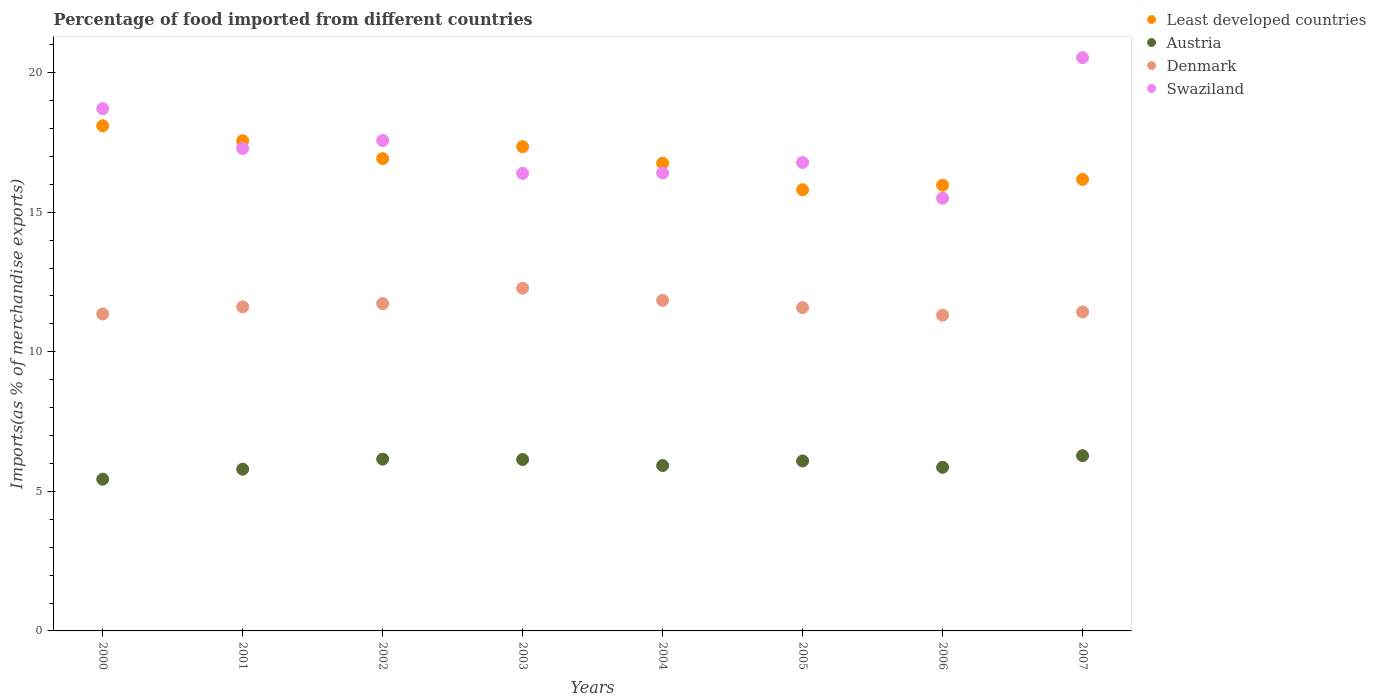What is the percentage of imports to different countries in Swaziland in 2006?
Offer a very short reply. 15.5. Across all years, what is the maximum percentage of imports to different countries in Austria?
Provide a succinct answer. 6.28. Across all years, what is the minimum percentage of imports to different countries in Least developed countries?
Offer a very short reply. 15.81. In which year was the percentage of imports to different countries in Denmark minimum?
Provide a short and direct response. 2006. What is the total percentage of imports to different countries in Denmark in the graph?
Provide a succinct answer. 93.14. What is the difference between the percentage of imports to different countries in Swaziland in 2000 and that in 2002?
Your answer should be very brief. 1.14. What is the difference between the percentage of imports to different countries in Swaziland in 2001 and the percentage of imports to different countries in Austria in 2005?
Offer a terse response. 11.2. What is the average percentage of imports to different countries in Swaziland per year?
Your response must be concise. 17.4. In the year 2000, what is the difference between the percentage of imports to different countries in Austria and percentage of imports to different countries in Least developed countries?
Make the answer very short. -12.66. In how many years, is the percentage of imports to different countries in Least developed countries greater than 2 %?
Provide a short and direct response. 8. What is the ratio of the percentage of imports to different countries in Austria in 2003 to that in 2006?
Give a very brief answer. 1.05. Is the percentage of imports to different countries in Denmark in 2003 less than that in 2006?
Offer a very short reply. No. Is the difference between the percentage of imports to different countries in Austria in 2001 and 2007 greater than the difference between the percentage of imports to different countries in Least developed countries in 2001 and 2007?
Your answer should be very brief. No. What is the difference between the highest and the second highest percentage of imports to different countries in Least developed countries?
Ensure brevity in your answer.  0.54. What is the difference between the highest and the lowest percentage of imports to different countries in Denmark?
Provide a succinct answer. 0.97. In how many years, is the percentage of imports to different countries in Denmark greater than the average percentage of imports to different countries in Denmark taken over all years?
Your response must be concise. 3. Is the sum of the percentage of imports to different countries in Least developed countries in 2005 and 2007 greater than the maximum percentage of imports to different countries in Austria across all years?
Keep it short and to the point. Yes. Is it the case that in every year, the sum of the percentage of imports to different countries in Denmark and percentage of imports to different countries in Austria  is greater than the percentage of imports to different countries in Least developed countries?
Offer a terse response. No. Does the percentage of imports to different countries in Swaziland monotonically increase over the years?
Your response must be concise. No. Is the percentage of imports to different countries in Austria strictly greater than the percentage of imports to different countries in Swaziland over the years?
Make the answer very short. No. What is the difference between two consecutive major ticks on the Y-axis?
Provide a succinct answer. 5. Are the values on the major ticks of Y-axis written in scientific E-notation?
Offer a terse response. No. Does the graph contain grids?
Your answer should be very brief. No. Where does the legend appear in the graph?
Your response must be concise. Top right. How many legend labels are there?
Offer a very short reply. 4. How are the legend labels stacked?
Your answer should be very brief. Vertical. What is the title of the graph?
Ensure brevity in your answer.  Percentage of food imported from different countries. Does "Upper middle income" appear as one of the legend labels in the graph?
Offer a very short reply. No. What is the label or title of the Y-axis?
Ensure brevity in your answer.  Imports(as % of merchandise exports). What is the Imports(as % of merchandise exports) of Least developed countries in 2000?
Provide a succinct answer. 18.1. What is the Imports(as % of merchandise exports) in Austria in 2000?
Offer a terse response. 5.44. What is the Imports(as % of merchandise exports) of Denmark in 2000?
Your response must be concise. 11.36. What is the Imports(as % of merchandise exports) of Swaziland in 2000?
Ensure brevity in your answer.  18.71. What is the Imports(as % of merchandise exports) in Least developed countries in 2001?
Offer a very short reply. 17.56. What is the Imports(as % of merchandise exports) in Austria in 2001?
Ensure brevity in your answer.  5.8. What is the Imports(as % of merchandise exports) in Denmark in 2001?
Offer a very short reply. 11.61. What is the Imports(as % of merchandise exports) in Swaziland in 2001?
Offer a very short reply. 17.29. What is the Imports(as % of merchandise exports) of Least developed countries in 2002?
Your response must be concise. 16.92. What is the Imports(as % of merchandise exports) of Austria in 2002?
Keep it short and to the point. 6.16. What is the Imports(as % of merchandise exports) in Denmark in 2002?
Offer a very short reply. 11.73. What is the Imports(as % of merchandise exports) in Swaziland in 2002?
Offer a terse response. 17.57. What is the Imports(as % of merchandise exports) of Least developed countries in 2003?
Offer a terse response. 17.35. What is the Imports(as % of merchandise exports) in Austria in 2003?
Your answer should be compact. 6.14. What is the Imports(as % of merchandise exports) in Denmark in 2003?
Your answer should be very brief. 12.28. What is the Imports(as % of merchandise exports) of Swaziland in 2003?
Make the answer very short. 16.39. What is the Imports(as % of merchandise exports) of Least developed countries in 2004?
Ensure brevity in your answer.  16.76. What is the Imports(as % of merchandise exports) in Austria in 2004?
Your answer should be compact. 5.92. What is the Imports(as % of merchandise exports) in Denmark in 2004?
Offer a very short reply. 11.84. What is the Imports(as % of merchandise exports) of Swaziland in 2004?
Offer a terse response. 16.41. What is the Imports(as % of merchandise exports) of Least developed countries in 2005?
Your response must be concise. 15.81. What is the Imports(as % of merchandise exports) in Austria in 2005?
Offer a terse response. 6.09. What is the Imports(as % of merchandise exports) in Denmark in 2005?
Offer a terse response. 11.58. What is the Imports(as % of merchandise exports) of Swaziland in 2005?
Offer a terse response. 16.78. What is the Imports(as % of merchandise exports) in Least developed countries in 2006?
Provide a succinct answer. 15.97. What is the Imports(as % of merchandise exports) in Austria in 2006?
Keep it short and to the point. 5.86. What is the Imports(as % of merchandise exports) of Denmark in 2006?
Your answer should be very brief. 11.31. What is the Imports(as % of merchandise exports) of Swaziland in 2006?
Make the answer very short. 15.5. What is the Imports(as % of merchandise exports) in Least developed countries in 2007?
Provide a short and direct response. 16.18. What is the Imports(as % of merchandise exports) of Austria in 2007?
Your answer should be compact. 6.28. What is the Imports(as % of merchandise exports) in Denmark in 2007?
Your answer should be very brief. 11.43. What is the Imports(as % of merchandise exports) in Swaziland in 2007?
Keep it short and to the point. 20.54. Across all years, what is the maximum Imports(as % of merchandise exports) in Least developed countries?
Ensure brevity in your answer.  18.1. Across all years, what is the maximum Imports(as % of merchandise exports) of Austria?
Offer a very short reply. 6.28. Across all years, what is the maximum Imports(as % of merchandise exports) of Denmark?
Provide a short and direct response. 12.28. Across all years, what is the maximum Imports(as % of merchandise exports) of Swaziland?
Offer a very short reply. 20.54. Across all years, what is the minimum Imports(as % of merchandise exports) in Least developed countries?
Provide a succinct answer. 15.81. Across all years, what is the minimum Imports(as % of merchandise exports) of Austria?
Offer a terse response. 5.44. Across all years, what is the minimum Imports(as % of merchandise exports) of Denmark?
Provide a succinct answer. 11.31. Across all years, what is the minimum Imports(as % of merchandise exports) in Swaziland?
Your answer should be very brief. 15.5. What is the total Imports(as % of merchandise exports) in Least developed countries in the graph?
Your response must be concise. 134.64. What is the total Imports(as % of merchandise exports) of Austria in the graph?
Provide a short and direct response. 47.68. What is the total Imports(as % of merchandise exports) in Denmark in the graph?
Offer a terse response. 93.14. What is the total Imports(as % of merchandise exports) of Swaziland in the graph?
Keep it short and to the point. 139.2. What is the difference between the Imports(as % of merchandise exports) in Least developed countries in 2000 and that in 2001?
Provide a short and direct response. 0.54. What is the difference between the Imports(as % of merchandise exports) of Austria in 2000 and that in 2001?
Keep it short and to the point. -0.36. What is the difference between the Imports(as % of merchandise exports) of Denmark in 2000 and that in 2001?
Ensure brevity in your answer.  -0.25. What is the difference between the Imports(as % of merchandise exports) of Swaziland in 2000 and that in 2001?
Offer a very short reply. 1.43. What is the difference between the Imports(as % of merchandise exports) in Least developed countries in 2000 and that in 2002?
Offer a terse response. 1.18. What is the difference between the Imports(as % of merchandise exports) in Austria in 2000 and that in 2002?
Offer a terse response. -0.72. What is the difference between the Imports(as % of merchandise exports) of Denmark in 2000 and that in 2002?
Your response must be concise. -0.37. What is the difference between the Imports(as % of merchandise exports) of Swaziland in 2000 and that in 2002?
Keep it short and to the point. 1.14. What is the difference between the Imports(as % of merchandise exports) in Least developed countries in 2000 and that in 2003?
Make the answer very short. 0.75. What is the difference between the Imports(as % of merchandise exports) in Austria in 2000 and that in 2003?
Your answer should be compact. -0.7. What is the difference between the Imports(as % of merchandise exports) of Denmark in 2000 and that in 2003?
Your answer should be very brief. -0.92. What is the difference between the Imports(as % of merchandise exports) in Swaziland in 2000 and that in 2003?
Your answer should be compact. 2.32. What is the difference between the Imports(as % of merchandise exports) in Least developed countries in 2000 and that in 2004?
Provide a short and direct response. 1.34. What is the difference between the Imports(as % of merchandise exports) of Austria in 2000 and that in 2004?
Make the answer very short. -0.49. What is the difference between the Imports(as % of merchandise exports) of Denmark in 2000 and that in 2004?
Provide a short and direct response. -0.49. What is the difference between the Imports(as % of merchandise exports) in Swaziland in 2000 and that in 2004?
Offer a terse response. 2.3. What is the difference between the Imports(as % of merchandise exports) in Least developed countries in 2000 and that in 2005?
Your response must be concise. 2.29. What is the difference between the Imports(as % of merchandise exports) of Austria in 2000 and that in 2005?
Give a very brief answer. -0.65. What is the difference between the Imports(as % of merchandise exports) in Denmark in 2000 and that in 2005?
Make the answer very short. -0.23. What is the difference between the Imports(as % of merchandise exports) in Swaziland in 2000 and that in 2005?
Your response must be concise. 1.93. What is the difference between the Imports(as % of merchandise exports) of Least developed countries in 2000 and that in 2006?
Provide a succinct answer. 2.13. What is the difference between the Imports(as % of merchandise exports) of Austria in 2000 and that in 2006?
Provide a succinct answer. -0.43. What is the difference between the Imports(as % of merchandise exports) in Denmark in 2000 and that in 2006?
Give a very brief answer. 0.04. What is the difference between the Imports(as % of merchandise exports) of Swaziland in 2000 and that in 2006?
Ensure brevity in your answer.  3.21. What is the difference between the Imports(as % of merchandise exports) of Least developed countries in 2000 and that in 2007?
Make the answer very short. 1.92. What is the difference between the Imports(as % of merchandise exports) of Austria in 2000 and that in 2007?
Provide a succinct answer. -0.84. What is the difference between the Imports(as % of merchandise exports) in Denmark in 2000 and that in 2007?
Provide a succinct answer. -0.07. What is the difference between the Imports(as % of merchandise exports) of Swaziland in 2000 and that in 2007?
Give a very brief answer. -1.83. What is the difference between the Imports(as % of merchandise exports) of Least developed countries in 2001 and that in 2002?
Provide a short and direct response. 0.64. What is the difference between the Imports(as % of merchandise exports) of Austria in 2001 and that in 2002?
Offer a terse response. -0.36. What is the difference between the Imports(as % of merchandise exports) in Denmark in 2001 and that in 2002?
Offer a terse response. -0.12. What is the difference between the Imports(as % of merchandise exports) in Swaziland in 2001 and that in 2002?
Keep it short and to the point. -0.28. What is the difference between the Imports(as % of merchandise exports) in Least developed countries in 2001 and that in 2003?
Give a very brief answer. 0.21. What is the difference between the Imports(as % of merchandise exports) of Austria in 2001 and that in 2003?
Your answer should be compact. -0.35. What is the difference between the Imports(as % of merchandise exports) of Denmark in 2001 and that in 2003?
Give a very brief answer. -0.67. What is the difference between the Imports(as % of merchandise exports) in Swaziland in 2001 and that in 2003?
Your answer should be compact. 0.89. What is the difference between the Imports(as % of merchandise exports) in Least developed countries in 2001 and that in 2004?
Make the answer very short. 0.81. What is the difference between the Imports(as % of merchandise exports) in Austria in 2001 and that in 2004?
Give a very brief answer. -0.13. What is the difference between the Imports(as % of merchandise exports) of Denmark in 2001 and that in 2004?
Give a very brief answer. -0.23. What is the difference between the Imports(as % of merchandise exports) of Swaziland in 2001 and that in 2004?
Ensure brevity in your answer.  0.88. What is the difference between the Imports(as % of merchandise exports) in Least developed countries in 2001 and that in 2005?
Offer a very short reply. 1.76. What is the difference between the Imports(as % of merchandise exports) in Austria in 2001 and that in 2005?
Keep it short and to the point. -0.29. What is the difference between the Imports(as % of merchandise exports) in Denmark in 2001 and that in 2005?
Provide a succinct answer. 0.03. What is the difference between the Imports(as % of merchandise exports) in Swaziland in 2001 and that in 2005?
Your answer should be very brief. 0.5. What is the difference between the Imports(as % of merchandise exports) of Least developed countries in 2001 and that in 2006?
Ensure brevity in your answer.  1.59. What is the difference between the Imports(as % of merchandise exports) of Austria in 2001 and that in 2006?
Keep it short and to the point. -0.07. What is the difference between the Imports(as % of merchandise exports) in Denmark in 2001 and that in 2006?
Make the answer very short. 0.3. What is the difference between the Imports(as % of merchandise exports) in Swaziland in 2001 and that in 2006?
Keep it short and to the point. 1.78. What is the difference between the Imports(as % of merchandise exports) in Least developed countries in 2001 and that in 2007?
Provide a short and direct response. 1.38. What is the difference between the Imports(as % of merchandise exports) of Austria in 2001 and that in 2007?
Provide a succinct answer. -0.48. What is the difference between the Imports(as % of merchandise exports) of Denmark in 2001 and that in 2007?
Make the answer very short. 0.18. What is the difference between the Imports(as % of merchandise exports) of Swaziland in 2001 and that in 2007?
Keep it short and to the point. -3.25. What is the difference between the Imports(as % of merchandise exports) in Least developed countries in 2002 and that in 2003?
Your answer should be compact. -0.43. What is the difference between the Imports(as % of merchandise exports) in Austria in 2002 and that in 2003?
Ensure brevity in your answer.  0.01. What is the difference between the Imports(as % of merchandise exports) of Denmark in 2002 and that in 2003?
Give a very brief answer. -0.55. What is the difference between the Imports(as % of merchandise exports) of Swaziland in 2002 and that in 2003?
Give a very brief answer. 1.18. What is the difference between the Imports(as % of merchandise exports) in Least developed countries in 2002 and that in 2004?
Your response must be concise. 0.17. What is the difference between the Imports(as % of merchandise exports) of Austria in 2002 and that in 2004?
Provide a short and direct response. 0.23. What is the difference between the Imports(as % of merchandise exports) of Denmark in 2002 and that in 2004?
Ensure brevity in your answer.  -0.11. What is the difference between the Imports(as % of merchandise exports) in Swaziland in 2002 and that in 2004?
Your answer should be very brief. 1.16. What is the difference between the Imports(as % of merchandise exports) of Least developed countries in 2002 and that in 2005?
Give a very brief answer. 1.11. What is the difference between the Imports(as % of merchandise exports) in Austria in 2002 and that in 2005?
Make the answer very short. 0.07. What is the difference between the Imports(as % of merchandise exports) of Denmark in 2002 and that in 2005?
Offer a terse response. 0.14. What is the difference between the Imports(as % of merchandise exports) in Swaziland in 2002 and that in 2005?
Your response must be concise. 0.79. What is the difference between the Imports(as % of merchandise exports) of Least developed countries in 2002 and that in 2006?
Provide a short and direct response. 0.95. What is the difference between the Imports(as % of merchandise exports) of Austria in 2002 and that in 2006?
Keep it short and to the point. 0.29. What is the difference between the Imports(as % of merchandise exports) in Denmark in 2002 and that in 2006?
Ensure brevity in your answer.  0.42. What is the difference between the Imports(as % of merchandise exports) in Swaziland in 2002 and that in 2006?
Give a very brief answer. 2.07. What is the difference between the Imports(as % of merchandise exports) of Least developed countries in 2002 and that in 2007?
Give a very brief answer. 0.74. What is the difference between the Imports(as % of merchandise exports) in Austria in 2002 and that in 2007?
Provide a short and direct response. -0.12. What is the difference between the Imports(as % of merchandise exports) in Denmark in 2002 and that in 2007?
Your response must be concise. 0.3. What is the difference between the Imports(as % of merchandise exports) of Swaziland in 2002 and that in 2007?
Give a very brief answer. -2.97. What is the difference between the Imports(as % of merchandise exports) of Least developed countries in 2003 and that in 2004?
Your response must be concise. 0.59. What is the difference between the Imports(as % of merchandise exports) of Austria in 2003 and that in 2004?
Ensure brevity in your answer.  0.22. What is the difference between the Imports(as % of merchandise exports) in Denmark in 2003 and that in 2004?
Provide a short and direct response. 0.44. What is the difference between the Imports(as % of merchandise exports) of Swaziland in 2003 and that in 2004?
Provide a short and direct response. -0.01. What is the difference between the Imports(as % of merchandise exports) in Least developed countries in 2003 and that in 2005?
Offer a terse response. 1.54. What is the difference between the Imports(as % of merchandise exports) of Austria in 2003 and that in 2005?
Ensure brevity in your answer.  0.05. What is the difference between the Imports(as % of merchandise exports) of Denmark in 2003 and that in 2005?
Make the answer very short. 0.69. What is the difference between the Imports(as % of merchandise exports) in Swaziland in 2003 and that in 2005?
Your answer should be very brief. -0.39. What is the difference between the Imports(as % of merchandise exports) in Least developed countries in 2003 and that in 2006?
Provide a succinct answer. 1.38. What is the difference between the Imports(as % of merchandise exports) of Austria in 2003 and that in 2006?
Give a very brief answer. 0.28. What is the difference between the Imports(as % of merchandise exports) of Denmark in 2003 and that in 2006?
Your response must be concise. 0.97. What is the difference between the Imports(as % of merchandise exports) in Swaziland in 2003 and that in 2006?
Offer a terse response. 0.89. What is the difference between the Imports(as % of merchandise exports) in Least developed countries in 2003 and that in 2007?
Offer a terse response. 1.17. What is the difference between the Imports(as % of merchandise exports) in Austria in 2003 and that in 2007?
Make the answer very short. -0.14. What is the difference between the Imports(as % of merchandise exports) of Denmark in 2003 and that in 2007?
Offer a terse response. 0.85. What is the difference between the Imports(as % of merchandise exports) of Swaziland in 2003 and that in 2007?
Provide a succinct answer. -4.14. What is the difference between the Imports(as % of merchandise exports) in Least developed countries in 2004 and that in 2005?
Your answer should be very brief. 0.95. What is the difference between the Imports(as % of merchandise exports) of Austria in 2004 and that in 2005?
Your answer should be compact. -0.16. What is the difference between the Imports(as % of merchandise exports) in Denmark in 2004 and that in 2005?
Provide a succinct answer. 0.26. What is the difference between the Imports(as % of merchandise exports) in Swaziland in 2004 and that in 2005?
Your response must be concise. -0.38. What is the difference between the Imports(as % of merchandise exports) of Least developed countries in 2004 and that in 2006?
Your response must be concise. 0.79. What is the difference between the Imports(as % of merchandise exports) of Austria in 2004 and that in 2006?
Keep it short and to the point. 0.06. What is the difference between the Imports(as % of merchandise exports) of Denmark in 2004 and that in 2006?
Give a very brief answer. 0.53. What is the difference between the Imports(as % of merchandise exports) in Swaziland in 2004 and that in 2006?
Make the answer very short. 0.9. What is the difference between the Imports(as % of merchandise exports) in Least developed countries in 2004 and that in 2007?
Offer a terse response. 0.58. What is the difference between the Imports(as % of merchandise exports) in Austria in 2004 and that in 2007?
Your answer should be very brief. -0.35. What is the difference between the Imports(as % of merchandise exports) in Denmark in 2004 and that in 2007?
Provide a succinct answer. 0.42. What is the difference between the Imports(as % of merchandise exports) in Swaziland in 2004 and that in 2007?
Ensure brevity in your answer.  -4.13. What is the difference between the Imports(as % of merchandise exports) in Least developed countries in 2005 and that in 2006?
Provide a short and direct response. -0.16. What is the difference between the Imports(as % of merchandise exports) of Austria in 2005 and that in 2006?
Ensure brevity in your answer.  0.23. What is the difference between the Imports(as % of merchandise exports) of Denmark in 2005 and that in 2006?
Provide a succinct answer. 0.27. What is the difference between the Imports(as % of merchandise exports) of Swaziland in 2005 and that in 2006?
Your answer should be compact. 1.28. What is the difference between the Imports(as % of merchandise exports) in Least developed countries in 2005 and that in 2007?
Make the answer very short. -0.37. What is the difference between the Imports(as % of merchandise exports) in Austria in 2005 and that in 2007?
Offer a very short reply. -0.19. What is the difference between the Imports(as % of merchandise exports) of Denmark in 2005 and that in 2007?
Offer a very short reply. 0.16. What is the difference between the Imports(as % of merchandise exports) of Swaziland in 2005 and that in 2007?
Provide a short and direct response. -3.76. What is the difference between the Imports(as % of merchandise exports) in Least developed countries in 2006 and that in 2007?
Provide a succinct answer. -0.21. What is the difference between the Imports(as % of merchandise exports) in Austria in 2006 and that in 2007?
Ensure brevity in your answer.  -0.41. What is the difference between the Imports(as % of merchandise exports) of Denmark in 2006 and that in 2007?
Offer a terse response. -0.11. What is the difference between the Imports(as % of merchandise exports) in Swaziland in 2006 and that in 2007?
Your response must be concise. -5.04. What is the difference between the Imports(as % of merchandise exports) in Least developed countries in 2000 and the Imports(as % of merchandise exports) in Austria in 2001?
Ensure brevity in your answer.  12.3. What is the difference between the Imports(as % of merchandise exports) of Least developed countries in 2000 and the Imports(as % of merchandise exports) of Denmark in 2001?
Provide a short and direct response. 6.49. What is the difference between the Imports(as % of merchandise exports) in Least developed countries in 2000 and the Imports(as % of merchandise exports) in Swaziland in 2001?
Give a very brief answer. 0.81. What is the difference between the Imports(as % of merchandise exports) in Austria in 2000 and the Imports(as % of merchandise exports) in Denmark in 2001?
Provide a succinct answer. -6.17. What is the difference between the Imports(as % of merchandise exports) of Austria in 2000 and the Imports(as % of merchandise exports) of Swaziland in 2001?
Give a very brief answer. -11.85. What is the difference between the Imports(as % of merchandise exports) in Denmark in 2000 and the Imports(as % of merchandise exports) in Swaziland in 2001?
Give a very brief answer. -5.93. What is the difference between the Imports(as % of merchandise exports) in Least developed countries in 2000 and the Imports(as % of merchandise exports) in Austria in 2002?
Give a very brief answer. 11.94. What is the difference between the Imports(as % of merchandise exports) of Least developed countries in 2000 and the Imports(as % of merchandise exports) of Denmark in 2002?
Offer a terse response. 6.37. What is the difference between the Imports(as % of merchandise exports) of Least developed countries in 2000 and the Imports(as % of merchandise exports) of Swaziland in 2002?
Keep it short and to the point. 0.53. What is the difference between the Imports(as % of merchandise exports) in Austria in 2000 and the Imports(as % of merchandise exports) in Denmark in 2002?
Offer a terse response. -6.29. What is the difference between the Imports(as % of merchandise exports) of Austria in 2000 and the Imports(as % of merchandise exports) of Swaziland in 2002?
Give a very brief answer. -12.13. What is the difference between the Imports(as % of merchandise exports) in Denmark in 2000 and the Imports(as % of merchandise exports) in Swaziland in 2002?
Your answer should be compact. -6.21. What is the difference between the Imports(as % of merchandise exports) of Least developed countries in 2000 and the Imports(as % of merchandise exports) of Austria in 2003?
Provide a succinct answer. 11.96. What is the difference between the Imports(as % of merchandise exports) of Least developed countries in 2000 and the Imports(as % of merchandise exports) of Denmark in 2003?
Provide a short and direct response. 5.82. What is the difference between the Imports(as % of merchandise exports) of Least developed countries in 2000 and the Imports(as % of merchandise exports) of Swaziland in 2003?
Provide a short and direct response. 1.7. What is the difference between the Imports(as % of merchandise exports) in Austria in 2000 and the Imports(as % of merchandise exports) in Denmark in 2003?
Offer a very short reply. -6.84. What is the difference between the Imports(as % of merchandise exports) of Austria in 2000 and the Imports(as % of merchandise exports) of Swaziland in 2003?
Provide a succinct answer. -10.96. What is the difference between the Imports(as % of merchandise exports) in Denmark in 2000 and the Imports(as % of merchandise exports) in Swaziland in 2003?
Provide a succinct answer. -5.04. What is the difference between the Imports(as % of merchandise exports) of Least developed countries in 2000 and the Imports(as % of merchandise exports) of Austria in 2004?
Provide a short and direct response. 12.17. What is the difference between the Imports(as % of merchandise exports) in Least developed countries in 2000 and the Imports(as % of merchandise exports) in Denmark in 2004?
Provide a short and direct response. 6.26. What is the difference between the Imports(as % of merchandise exports) in Least developed countries in 2000 and the Imports(as % of merchandise exports) in Swaziland in 2004?
Provide a short and direct response. 1.69. What is the difference between the Imports(as % of merchandise exports) in Austria in 2000 and the Imports(as % of merchandise exports) in Denmark in 2004?
Provide a succinct answer. -6.41. What is the difference between the Imports(as % of merchandise exports) in Austria in 2000 and the Imports(as % of merchandise exports) in Swaziland in 2004?
Give a very brief answer. -10.97. What is the difference between the Imports(as % of merchandise exports) in Denmark in 2000 and the Imports(as % of merchandise exports) in Swaziland in 2004?
Offer a very short reply. -5.05. What is the difference between the Imports(as % of merchandise exports) in Least developed countries in 2000 and the Imports(as % of merchandise exports) in Austria in 2005?
Make the answer very short. 12.01. What is the difference between the Imports(as % of merchandise exports) in Least developed countries in 2000 and the Imports(as % of merchandise exports) in Denmark in 2005?
Provide a succinct answer. 6.52. What is the difference between the Imports(as % of merchandise exports) in Least developed countries in 2000 and the Imports(as % of merchandise exports) in Swaziland in 2005?
Provide a succinct answer. 1.32. What is the difference between the Imports(as % of merchandise exports) in Austria in 2000 and the Imports(as % of merchandise exports) in Denmark in 2005?
Give a very brief answer. -6.15. What is the difference between the Imports(as % of merchandise exports) of Austria in 2000 and the Imports(as % of merchandise exports) of Swaziland in 2005?
Your answer should be compact. -11.35. What is the difference between the Imports(as % of merchandise exports) in Denmark in 2000 and the Imports(as % of merchandise exports) in Swaziland in 2005?
Your response must be concise. -5.43. What is the difference between the Imports(as % of merchandise exports) in Least developed countries in 2000 and the Imports(as % of merchandise exports) in Austria in 2006?
Give a very brief answer. 12.24. What is the difference between the Imports(as % of merchandise exports) in Least developed countries in 2000 and the Imports(as % of merchandise exports) in Denmark in 2006?
Your response must be concise. 6.79. What is the difference between the Imports(as % of merchandise exports) of Least developed countries in 2000 and the Imports(as % of merchandise exports) of Swaziland in 2006?
Offer a very short reply. 2.6. What is the difference between the Imports(as % of merchandise exports) of Austria in 2000 and the Imports(as % of merchandise exports) of Denmark in 2006?
Give a very brief answer. -5.88. What is the difference between the Imports(as % of merchandise exports) of Austria in 2000 and the Imports(as % of merchandise exports) of Swaziland in 2006?
Your response must be concise. -10.07. What is the difference between the Imports(as % of merchandise exports) of Denmark in 2000 and the Imports(as % of merchandise exports) of Swaziland in 2006?
Provide a succinct answer. -4.15. What is the difference between the Imports(as % of merchandise exports) of Least developed countries in 2000 and the Imports(as % of merchandise exports) of Austria in 2007?
Ensure brevity in your answer.  11.82. What is the difference between the Imports(as % of merchandise exports) in Least developed countries in 2000 and the Imports(as % of merchandise exports) in Denmark in 2007?
Your answer should be very brief. 6.67. What is the difference between the Imports(as % of merchandise exports) in Least developed countries in 2000 and the Imports(as % of merchandise exports) in Swaziland in 2007?
Offer a terse response. -2.44. What is the difference between the Imports(as % of merchandise exports) of Austria in 2000 and the Imports(as % of merchandise exports) of Denmark in 2007?
Offer a very short reply. -5.99. What is the difference between the Imports(as % of merchandise exports) in Austria in 2000 and the Imports(as % of merchandise exports) in Swaziland in 2007?
Offer a terse response. -15.1. What is the difference between the Imports(as % of merchandise exports) in Denmark in 2000 and the Imports(as % of merchandise exports) in Swaziland in 2007?
Make the answer very short. -9.18. What is the difference between the Imports(as % of merchandise exports) in Least developed countries in 2001 and the Imports(as % of merchandise exports) in Austria in 2002?
Keep it short and to the point. 11.41. What is the difference between the Imports(as % of merchandise exports) of Least developed countries in 2001 and the Imports(as % of merchandise exports) of Denmark in 2002?
Offer a very short reply. 5.83. What is the difference between the Imports(as % of merchandise exports) in Least developed countries in 2001 and the Imports(as % of merchandise exports) in Swaziland in 2002?
Your response must be concise. -0.01. What is the difference between the Imports(as % of merchandise exports) of Austria in 2001 and the Imports(as % of merchandise exports) of Denmark in 2002?
Offer a very short reply. -5.93. What is the difference between the Imports(as % of merchandise exports) of Austria in 2001 and the Imports(as % of merchandise exports) of Swaziland in 2002?
Provide a succinct answer. -11.78. What is the difference between the Imports(as % of merchandise exports) in Denmark in 2001 and the Imports(as % of merchandise exports) in Swaziland in 2002?
Keep it short and to the point. -5.96. What is the difference between the Imports(as % of merchandise exports) in Least developed countries in 2001 and the Imports(as % of merchandise exports) in Austria in 2003?
Provide a short and direct response. 11.42. What is the difference between the Imports(as % of merchandise exports) of Least developed countries in 2001 and the Imports(as % of merchandise exports) of Denmark in 2003?
Your answer should be compact. 5.28. What is the difference between the Imports(as % of merchandise exports) of Least developed countries in 2001 and the Imports(as % of merchandise exports) of Swaziland in 2003?
Your response must be concise. 1.17. What is the difference between the Imports(as % of merchandise exports) in Austria in 2001 and the Imports(as % of merchandise exports) in Denmark in 2003?
Offer a very short reply. -6.48. What is the difference between the Imports(as % of merchandise exports) in Austria in 2001 and the Imports(as % of merchandise exports) in Swaziland in 2003?
Offer a very short reply. -10.6. What is the difference between the Imports(as % of merchandise exports) in Denmark in 2001 and the Imports(as % of merchandise exports) in Swaziland in 2003?
Offer a very short reply. -4.78. What is the difference between the Imports(as % of merchandise exports) of Least developed countries in 2001 and the Imports(as % of merchandise exports) of Austria in 2004?
Provide a succinct answer. 11.64. What is the difference between the Imports(as % of merchandise exports) in Least developed countries in 2001 and the Imports(as % of merchandise exports) in Denmark in 2004?
Ensure brevity in your answer.  5.72. What is the difference between the Imports(as % of merchandise exports) of Least developed countries in 2001 and the Imports(as % of merchandise exports) of Swaziland in 2004?
Keep it short and to the point. 1.15. What is the difference between the Imports(as % of merchandise exports) of Austria in 2001 and the Imports(as % of merchandise exports) of Denmark in 2004?
Your answer should be very brief. -6.05. What is the difference between the Imports(as % of merchandise exports) of Austria in 2001 and the Imports(as % of merchandise exports) of Swaziland in 2004?
Make the answer very short. -10.61. What is the difference between the Imports(as % of merchandise exports) of Denmark in 2001 and the Imports(as % of merchandise exports) of Swaziland in 2004?
Offer a terse response. -4.8. What is the difference between the Imports(as % of merchandise exports) of Least developed countries in 2001 and the Imports(as % of merchandise exports) of Austria in 2005?
Ensure brevity in your answer.  11.47. What is the difference between the Imports(as % of merchandise exports) in Least developed countries in 2001 and the Imports(as % of merchandise exports) in Denmark in 2005?
Make the answer very short. 5.98. What is the difference between the Imports(as % of merchandise exports) in Least developed countries in 2001 and the Imports(as % of merchandise exports) in Swaziland in 2005?
Give a very brief answer. 0.78. What is the difference between the Imports(as % of merchandise exports) of Austria in 2001 and the Imports(as % of merchandise exports) of Denmark in 2005?
Your response must be concise. -5.79. What is the difference between the Imports(as % of merchandise exports) in Austria in 2001 and the Imports(as % of merchandise exports) in Swaziland in 2005?
Ensure brevity in your answer.  -10.99. What is the difference between the Imports(as % of merchandise exports) in Denmark in 2001 and the Imports(as % of merchandise exports) in Swaziland in 2005?
Ensure brevity in your answer.  -5.17. What is the difference between the Imports(as % of merchandise exports) of Least developed countries in 2001 and the Imports(as % of merchandise exports) of Austria in 2006?
Provide a succinct answer. 11.7. What is the difference between the Imports(as % of merchandise exports) in Least developed countries in 2001 and the Imports(as % of merchandise exports) in Denmark in 2006?
Provide a succinct answer. 6.25. What is the difference between the Imports(as % of merchandise exports) in Least developed countries in 2001 and the Imports(as % of merchandise exports) in Swaziland in 2006?
Offer a terse response. 2.06. What is the difference between the Imports(as % of merchandise exports) in Austria in 2001 and the Imports(as % of merchandise exports) in Denmark in 2006?
Provide a succinct answer. -5.52. What is the difference between the Imports(as % of merchandise exports) of Austria in 2001 and the Imports(as % of merchandise exports) of Swaziland in 2006?
Your response must be concise. -9.71. What is the difference between the Imports(as % of merchandise exports) in Denmark in 2001 and the Imports(as % of merchandise exports) in Swaziland in 2006?
Your response must be concise. -3.89. What is the difference between the Imports(as % of merchandise exports) in Least developed countries in 2001 and the Imports(as % of merchandise exports) in Austria in 2007?
Give a very brief answer. 11.29. What is the difference between the Imports(as % of merchandise exports) in Least developed countries in 2001 and the Imports(as % of merchandise exports) in Denmark in 2007?
Provide a short and direct response. 6.14. What is the difference between the Imports(as % of merchandise exports) of Least developed countries in 2001 and the Imports(as % of merchandise exports) of Swaziland in 2007?
Offer a very short reply. -2.98. What is the difference between the Imports(as % of merchandise exports) in Austria in 2001 and the Imports(as % of merchandise exports) in Denmark in 2007?
Your response must be concise. -5.63. What is the difference between the Imports(as % of merchandise exports) of Austria in 2001 and the Imports(as % of merchandise exports) of Swaziland in 2007?
Ensure brevity in your answer.  -14.74. What is the difference between the Imports(as % of merchandise exports) of Denmark in 2001 and the Imports(as % of merchandise exports) of Swaziland in 2007?
Make the answer very short. -8.93. What is the difference between the Imports(as % of merchandise exports) of Least developed countries in 2002 and the Imports(as % of merchandise exports) of Austria in 2003?
Your answer should be compact. 10.78. What is the difference between the Imports(as % of merchandise exports) of Least developed countries in 2002 and the Imports(as % of merchandise exports) of Denmark in 2003?
Your answer should be compact. 4.64. What is the difference between the Imports(as % of merchandise exports) in Least developed countries in 2002 and the Imports(as % of merchandise exports) in Swaziland in 2003?
Give a very brief answer. 0.53. What is the difference between the Imports(as % of merchandise exports) in Austria in 2002 and the Imports(as % of merchandise exports) in Denmark in 2003?
Offer a terse response. -6.12. What is the difference between the Imports(as % of merchandise exports) in Austria in 2002 and the Imports(as % of merchandise exports) in Swaziland in 2003?
Give a very brief answer. -10.24. What is the difference between the Imports(as % of merchandise exports) of Denmark in 2002 and the Imports(as % of merchandise exports) of Swaziland in 2003?
Offer a very short reply. -4.67. What is the difference between the Imports(as % of merchandise exports) of Least developed countries in 2002 and the Imports(as % of merchandise exports) of Austria in 2004?
Make the answer very short. 11. What is the difference between the Imports(as % of merchandise exports) of Least developed countries in 2002 and the Imports(as % of merchandise exports) of Denmark in 2004?
Your answer should be compact. 5.08. What is the difference between the Imports(as % of merchandise exports) of Least developed countries in 2002 and the Imports(as % of merchandise exports) of Swaziland in 2004?
Provide a succinct answer. 0.51. What is the difference between the Imports(as % of merchandise exports) of Austria in 2002 and the Imports(as % of merchandise exports) of Denmark in 2004?
Your answer should be compact. -5.69. What is the difference between the Imports(as % of merchandise exports) of Austria in 2002 and the Imports(as % of merchandise exports) of Swaziland in 2004?
Your response must be concise. -10.25. What is the difference between the Imports(as % of merchandise exports) in Denmark in 2002 and the Imports(as % of merchandise exports) in Swaziland in 2004?
Ensure brevity in your answer.  -4.68. What is the difference between the Imports(as % of merchandise exports) of Least developed countries in 2002 and the Imports(as % of merchandise exports) of Austria in 2005?
Offer a terse response. 10.83. What is the difference between the Imports(as % of merchandise exports) of Least developed countries in 2002 and the Imports(as % of merchandise exports) of Denmark in 2005?
Provide a short and direct response. 5.34. What is the difference between the Imports(as % of merchandise exports) in Least developed countries in 2002 and the Imports(as % of merchandise exports) in Swaziland in 2005?
Your answer should be compact. 0.14. What is the difference between the Imports(as % of merchandise exports) of Austria in 2002 and the Imports(as % of merchandise exports) of Denmark in 2005?
Offer a terse response. -5.43. What is the difference between the Imports(as % of merchandise exports) of Austria in 2002 and the Imports(as % of merchandise exports) of Swaziland in 2005?
Offer a very short reply. -10.63. What is the difference between the Imports(as % of merchandise exports) of Denmark in 2002 and the Imports(as % of merchandise exports) of Swaziland in 2005?
Provide a short and direct response. -5.05. What is the difference between the Imports(as % of merchandise exports) of Least developed countries in 2002 and the Imports(as % of merchandise exports) of Austria in 2006?
Offer a very short reply. 11.06. What is the difference between the Imports(as % of merchandise exports) of Least developed countries in 2002 and the Imports(as % of merchandise exports) of Denmark in 2006?
Your response must be concise. 5.61. What is the difference between the Imports(as % of merchandise exports) in Least developed countries in 2002 and the Imports(as % of merchandise exports) in Swaziland in 2006?
Offer a terse response. 1.42. What is the difference between the Imports(as % of merchandise exports) in Austria in 2002 and the Imports(as % of merchandise exports) in Denmark in 2006?
Give a very brief answer. -5.16. What is the difference between the Imports(as % of merchandise exports) in Austria in 2002 and the Imports(as % of merchandise exports) in Swaziland in 2006?
Your response must be concise. -9.35. What is the difference between the Imports(as % of merchandise exports) of Denmark in 2002 and the Imports(as % of merchandise exports) of Swaziland in 2006?
Make the answer very short. -3.78. What is the difference between the Imports(as % of merchandise exports) of Least developed countries in 2002 and the Imports(as % of merchandise exports) of Austria in 2007?
Provide a short and direct response. 10.64. What is the difference between the Imports(as % of merchandise exports) of Least developed countries in 2002 and the Imports(as % of merchandise exports) of Denmark in 2007?
Keep it short and to the point. 5.5. What is the difference between the Imports(as % of merchandise exports) of Least developed countries in 2002 and the Imports(as % of merchandise exports) of Swaziland in 2007?
Ensure brevity in your answer.  -3.62. What is the difference between the Imports(as % of merchandise exports) of Austria in 2002 and the Imports(as % of merchandise exports) of Denmark in 2007?
Your answer should be compact. -5.27. What is the difference between the Imports(as % of merchandise exports) of Austria in 2002 and the Imports(as % of merchandise exports) of Swaziland in 2007?
Provide a short and direct response. -14.38. What is the difference between the Imports(as % of merchandise exports) in Denmark in 2002 and the Imports(as % of merchandise exports) in Swaziland in 2007?
Provide a succinct answer. -8.81. What is the difference between the Imports(as % of merchandise exports) of Least developed countries in 2003 and the Imports(as % of merchandise exports) of Austria in 2004?
Ensure brevity in your answer.  11.42. What is the difference between the Imports(as % of merchandise exports) in Least developed countries in 2003 and the Imports(as % of merchandise exports) in Denmark in 2004?
Provide a short and direct response. 5.51. What is the difference between the Imports(as % of merchandise exports) in Least developed countries in 2003 and the Imports(as % of merchandise exports) in Swaziland in 2004?
Your answer should be compact. 0.94. What is the difference between the Imports(as % of merchandise exports) of Austria in 2003 and the Imports(as % of merchandise exports) of Denmark in 2004?
Offer a terse response. -5.7. What is the difference between the Imports(as % of merchandise exports) in Austria in 2003 and the Imports(as % of merchandise exports) in Swaziland in 2004?
Make the answer very short. -10.27. What is the difference between the Imports(as % of merchandise exports) in Denmark in 2003 and the Imports(as % of merchandise exports) in Swaziland in 2004?
Your answer should be compact. -4.13. What is the difference between the Imports(as % of merchandise exports) in Least developed countries in 2003 and the Imports(as % of merchandise exports) in Austria in 2005?
Offer a terse response. 11.26. What is the difference between the Imports(as % of merchandise exports) in Least developed countries in 2003 and the Imports(as % of merchandise exports) in Denmark in 2005?
Give a very brief answer. 5.76. What is the difference between the Imports(as % of merchandise exports) of Least developed countries in 2003 and the Imports(as % of merchandise exports) of Swaziland in 2005?
Offer a very short reply. 0.57. What is the difference between the Imports(as % of merchandise exports) of Austria in 2003 and the Imports(as % of merchandise exports) of Denmark in 2005?
Provide a succinct answer. -5.44. What is the difference between the Imports(as % of merchandise exports) in Austria in 2003 and the Imports(as % of merchandise exports) in Swaziland in 2005?
Your answer should be compact. -10.64. What is the difference between the Imports(as % of merchandise exports) in Denmark in 2003 and the Imports(as % of merchandise exports) in Swaziland in 2005?
Keep it short and to the point. -4.5. What is the difference between the Imports(as % of merchandise exports) in Least developed countries in 2003 and the Imports(as % of merchandise exports) in Austria in 2006?
Ensure brevity in your answer.  11.49. What is the difference between the Imports(as % of merchandise exports) in Least developed countries in 2003 and the Imports(as % of merchandise exports) in Denmark in 2006?
Offer a terse response. 6.04. What is the difference between the Imports(as % of merchandise exports) in Least developed countries in 2003 and the Imports(as % of merchandise exports) in Swaziland in 2006?
Give a very brief answer. 1.84. What is the difference between the Imports(as % of merchandise exports) of Austria in 2003 and the Imports(as % of merchandise exports) of Denmark in 2006?
Make the answer very short. -5.17. What is the difference between the Imports(as % of merchandise exports) of Austria in 2003 and the Imports(as % of merchandise exports) of Swaziland in 2006?
Provide a short and direct response. -9.36. What is the difference between the Imports(as % of merchandise exports) of Denmark in 2003 and the Imports(as % of merchandise exports) of Swaziland in 2006?
Make the answer very short. -3.23. What is the difference between the Imports(as % of merchandise exports) of Least developed countries in 2003 and the Imports(as % of merchandise exports) of Austria in 2007?
Offer a terse response. 11.07. What is the difference between the Imports(as % of merchandise exports) in Least developed countries in 2003 and the Imports(as % of merchandise exports) in Denmark in 2007?
Offer a terse response. 5.92. What is the difference between the Imports(as % of merchandise exports) in Least developed countries in 2003 and the Imports(as % of merchandise exports) in Swaziland in 2007?
Provide a short and direct response. -3.19. What is the difference between the Imports(as % of merchandise exports) of Austria in 2003 and the Imports(as % of merchandise exports) of Denmark in 2007?
Your answer should be compact. -5.29. What is the difference between the Imports(as % of merchandise exports) of Austria in 2003 and the Imports(as % of merchandise exports) of Swaziland in 2007?
Your answer should be very brief. -14.4. What is the difference between the Imports(as % of merchandise exports) in Denmark in 2003 and the Imports(as % of merchandise exports) in Swaziland in 2007?
Provide a short and direct response. -8.26. What is the difference between the Imports(as % of merchandise exports) of Least developed countries in 2004 and the Imports(as % of merchandise exports) of Austria in 2005?
Offer a very short reply. 10.67. What is the difference between the Imports(as % of merchandise exports) of Least developed countries in 2004 and the Imports(as % of merchandise exports) of Denmark in 2005?
Your answer should be compact. 5.17. What is the difference between the Imports(as % of merchandise exports) in Least developed countries in 2004 and the Imports(as % of merchandise exports) in Swaziland in 2005?
Make the answer very short. -0.03. What is the difference between the Imports(as % of merchandise exports) of Austria in 2004 and the Imports(as % of merchandise exports) of Denmark in 2005?
Provide a succinct answer. -5.66. What is the difference between the Imports(as % of merchandise exports) of Austria in 2004 and the Imports(as % of merchandise exports) of Swaziland in 2005?
Provide a succinct answer. -10.86. What is the difference between the Imports(as % of merchandise exports) in Denmark in 2004 and the Imports(as % of merchandise exports) in Swaziland in 2005?
Your answer should be compact. -4.94. What is the difference between the Imports(as % of merchandise exports) in Least developed countries in 2004 and the Imports(as % of merchandise exports) in Austria in 2006?
Keep it short and to the point. 10.89. What is the difference between the Imports(as % of merchandise exports) of Least developed countries in 2004 and the Imports(as % of merchandise exports) of Denmark in 2006?
Make the answer very short. 5.44. What is the difference between the Imports(as % of merchandise exports) of Least developed countries in 2004 and the Imports(as % of merchandise exports) of Swaziland in 2006?
Provide a succinct answer. 1.25. What is the difference between the Imports(as % of merchandise exports) in Austria in 2004 and the Imports(as % of merchandise exports) in Denmark in 2006?
Your answer should be very brief. -5.39. What is the difference between the Imports(as % of merchandise exports) of Austria in 2004 and the Imports(as % of merchandise exports) of Swaziland in 2006?
Provide a succinct answer. -9.58. What is the difference between the Imports(as % of merchandise exports) of Denmark in 2004 and the Imports(as % of merchandise exports) of Swaziland in 2006?
Provide a succinct answer. -3.66. What is the difference between the Imports(as % of merchandise exports) in Least developed countries in 2004 and the Imports(as % of merchandise exports) in Austria in 2007?
Provide a succinct answer. 10.48. What is the difference between the Imports(as % of merchandise exports) of Least developed countries in 2004 and the Imports(as % of merchandise exports) of Denmark in 2007?
Provide a short and direct response. 5.33. What is the difference between the Imports(as % of merchandise exports) of Least developed countries in 2004 and the Imports(as % of merchandise exports) of Swaziland in 2007?
Ensure brevity in your answer.  -3.78. What is the difference between the Imports(as % of merchandise exports) in Austria in 2004 and the Imports(as % of merchandise exports) in Denmark in 2007?
Offer a very short reply. -5.5. What is the difference between the Imports(as % of merchandise exports) in Austria in 2004 and the Imports(as % of merchandise exports) in Swaziland in 2007?
Your answer should be compact. -14.61. What is the difference between the Imports(as % of merchandise exports) in Denmark in 2004 and the Imports(as % of merchandise exports) in Swaziland in 2007?
Offer a terse response. -8.7. What is the difference between the Imports(as % of merchandise exports) in Least developed countries in 2005 and the Imports(as % of merchandise exports) in Austria in 2006?
Provide a short and direct response. 9.94. What is the difference between the Imports(as % of merchandise exports) of Least developed countries in 2005 and the Imports(as % of merchandise exports) of Denmark in 2006?
Provide a short and direct response. 4.49. What is the difference between the Imports(as % of merchandise exports) in Least developed countries in 2005 and the Imports(as % of merchandise exports) in Swaziland in 2006?
Offer a very short reply. 0.3. What is the difference between the Imports(as % of merchandise exports) of Austria in 2005 and the Imports(as % of merchandise exports) of Denmark in 2006?
Your response must be concise. -5.22. What is the difference between the Imports(as % of merchandise exports) in Austria in 2005 and the Imports(as % of merchandise exports) in Swaziland in 2006?
Offer a terse response. -9.41. What is the difference between the Imports(as % of merchandise exports) in Denmark in 2005 and the Imports(as % of merchandise exports) in Swaziland in 2006?
Keep it short and to the point. -3.92. What is the difference between the Imports(as % of merchandise exports) of Least developed countries in 2005 and the Imports(as % of merchandise exports) of Austria in 2007?
Your answer should be very brief. 9.53. What is the difference between the Imports(as % of merchandise exports) of Least developed countries in 2005 and the Imports(as % of merchandise exports) of Denmark in 2007?
Provide a short and direct response. 4.38. What is the difference between the Imports(as % of merchandise exports) in Least developed countries in 2005 and the Imports(as % of merchandise exports) in Swaziland in 2007?
Your response must be concise. -4.73. What is the difference between the Imports(as % of merchandise exports) of Austria in 2005 and the Imports(as % of merchandise exports) of Denmark in 2007?
Your answer should be compact. -5.34. What is the difference between the Imports(as % of merchandise exports) in Austria in 2005 and the Imports(as % of merchandise exports) in Swaziland in 2007?
Your answer should be compact. -14.45. What is the difference between the Imports(as % of merchandise exports) in Denmark in 2005 and the Imports(as % of merchandise exports) in Swaziland in 2007?
Offer a very short reply. -8.96. What is the difference between the Imports(as % of merchandise exports) in Least developed countries in 2006 and the Imports(as % of merchandise exports) in Austria in 2007?
Ensure brevity in your answer.  9.69. What is the difference between the Imports(as % of merchandise exports) of Least developed countries in 2006 and the Imports(as % of merchandise exports) of Denmark in 2007?
Your answer should be compact. 4.54. What is the difference between the Imports(as % of merchandise exports) of Least developed countries in 2006 and the Imports(as % of merchandise exports) of Swaziland in 2007?
Offer a very short reply. -4.57. What is the difference between the Imports(as % of merchandise exports) in Austria in 2006 and the Imports(as % of merchandise exports) in Denmark in 2007?
Ensure brevity in your answer.  -5.56. What is the difference between the Imports(as % of merchandise exports) of Austria in 2006 and the Imports(as % of merchandise exports) of Swaziland in 2007?
Keep it short and to the point. -14.68. What is the difference between the Imports(as % of merchandise exports) in Denmark in 2006 and the Imports(as % of merchandise exports) in Swaziland in 2007?
Your answer should be compact. -9.23. What is the average Imports(as % of merchandise exports) of Least developed countries per year?
Provide a short and direct response. 16.83. What is the average Imports(as % of merchandise exports) of Austria per year?
Provide a short and direct response. 5.96. What is the average Imports(as % of merchandise exports) in Denmark per year?
Your answer should be very brief. 11.64. What is the average Imports(as % of merchandise exports) of Swaziland per year?
Offer a terse response. 17.4. In the year 2000, what is the difference between the Imports(as % of merchandise exports) in Least developed countries and Imports(as % of merchandise exports) in Austria?
Your answer should be compact. 12.66. In the year 2000, what is the difference between the Imports(as % of merchandise exports) in Least developed countries and Imports(as % of merchandise exports) in Denmark?
Give a very brief answer. 6.74. In the year 2000, what is the difference between the Imports(as % of merchandise exports) of Least developed countries and Imports(as % of merchandise exports) of Swaziland?
Your answer should be compact. -0.61. In the year 2000, what is the difference between the Imports(as % of merchandise exports) in Austria and Imports(as % of merchandise exports) in Denmark?
Ensure brevity in your answer.  -5.92. In the year 2000, what is the difference between the Imports(as % of merchandise exports) in Austria and Imports(as % of merchandise exports) in Swaziland?
Provide a succinct answer. -13.28. In the year 2000, what is the difference between the Imports(as % of merchandise exports) of Denmark and Imports(as % of merchandise exports) of Swaziland?
Offer a terse response. -7.36. In the year 2001, what is the difference between the Imports(as % of merchandise exports) in Least developed countries and Imports(as % of merchandise exports) in Austria?
Ensure brevity in your answer.  11.77. In the year 2001, what is the difference between the Imports(as % of merchandise exports) of Least developed countries and Imports(as % of merchandise exports) of Denmark?
Offer a terse response. 5.95. In the year 2001, what is the difference between the Imports(as % of merchandise exports) of Least developed countries and Imports(as % of merchandise exports) of Swaziland?
Offer a very short reply. 0.28. In the year 2001, what is the difference between the Imports(as % of merchandise exports) of Austria and Imports(as % of merchandise exports) of Denmark?
Ensure brevity in your answer.  -5.81. In the year 2001, what is the difference between the Imports(as % of merchandise exports) of Austria and Imports(as % of merchandise exports) of Swaziland?
Your response must be concise. -11.49. In the year 2001, what is the difference between the Imports(as % of merchandise exports) of Denmark and Imports(as % of merchandise exports) of Swaziland?
Your answer should be very brief. -5.68. In the year 2002, what is the difference between the Imports(as % of merchandise exports) in Least developed countries and Imports(as % of merchandise exports) in Austria?
Ensure brevity in your answer.  10.77. In the year 2002, what is the difference between the Imports(as % of merchandise exports) in Least developed countries and Imports(as % of merchandise exports) in Denmark?
Offer a very short reply. 5.19. In the year 2002, what is the difference between the Imports(as % of merchandise exports) of Least developed countries and Imports(as % of merchandise exports) of Swaziland?
Offer a very short reply. -0.65. In the year 2002, what is the difference between the Imports(as % of merchandise exports) in Austria and Imports(as % of merchandise exports) in Denmark?
Offer a very short reply. -5.57. In the year 2002, what is the difference between the Imports(as % of merchandise exports) in Austria and Imports(as % of merchandise exports) in Swaziland?
Keep it short and to the point. -11.42. In the year 2002, what is the difference between the Imports(as % of merchandise exports) of Denmark and Imports(as % of merchandise exports) of Swaziland?
Make the answer very short. -5.84. In the year 2003, what is the difference between the Imports(as % of merchandise exports) in Least developed countries and Imports(as % of merchandise exports) in Austria?
Give a very brief answer. 11.21. In the year 2003, what is the difference between the Imports(as % of merchandise exports) in Least developed countries and Imports(as % of merchandise exports) in Denmark?
Provide a short and direct response. 5.07. In the year 2003, what is the difference between the Imports(as % of merchandise exports) of Least developed countries and Imports(as % of merchandise exports) of Swaziland?
Make the answer very short. 0.95. In the year 2003, what is the difference between the Imports(as % of merchandise exports) in Austria and Imports(as % of merchandise exports) in Denmark?
Offer a very short reply. -6.14. In the year 2003, what is the difference between the Imports(as % of merchandise exports) of Austria and Imports(as % of merchandise exports) of Swaziland?
Make the answer very short. -10.25. In the year 2003, what is the difference between the Imports(as % of merchandise exports) of Denmark and Imports(as % of merchandise exports) of Swaziland?
Offer a very short reply. -4.12. In the year 2004, what is the difference between the Imports(as % of merchandise exports) in Least developed countries and Imports(as % of merchandise exports) in Austria?
Your response must be concise. 10.83. In the year 2004, what is the difference between the Imports(as % of merchandise exports) in Least developed countries and Imports(as % of merchandise exports) in Denmark?
Offer a very short reply. 4.91. In the year 2004, what is the difference between the Imports(as % of merchandise exports) in Least developed countries and Imports(as % of merchandise exports) in Swaziland?
Your answer should be compact. 0.35. In the year 2004, what is the difference between the Imports(as % of merchandise exports) of Austria and Imports(as % of merchandise exports) of Denmark?
Ensure brevity in your answer.  -5.92. In the year 2004, what is the difference between the Imports(as % of merchandise exports) in Austria and Imports(as % of merchandise exports) in Swaziland?
Offer a very short reply. -10.48. In the year 2004, what is the difference between the Imports(as % of merchandise exports) in Denmark and Imports(as % of merchandise exports) in Swaziland?
Provide a short and direct response. -4.57. In the year 2005, what is the difference between the Imports(as % of merchandise exports) in Least developed countries and Imports(as % of merchandise exports) in Austria?
Your answer should be very brief. 9.72. In the year 2005, what is the difference between the Imports(as % of merchandise exports) in Least developed countries and Imports(as % of merchandise exports) in Denmark?
Your answer should be compact. 4.22. In the year 2005, what is the difference between the Imports(as % of merchandise exports) in Least developed countries and Imports(as % of merchandise exports) in Swaziland?
Offer a very short reply. -0.98. In the year 2005, what is the difference between the Imports(as % of merchandise exports) in Austria and Imports(as % of merchandise exports) in Denmark?
Your answer should be compact. -5.49. In the year 2005, what is the difference between the Imports(as % of merchandise exports) of Austria and Imports(as % of merchandise exports) of Swaziland?
Provide a short and direct response. -10.69. In the year 2005, what is the difference between the Imports(as % of merchandise exports) of Denmark and Imports(as % of merchandise exports) of Swaziland?
Your answer should be very brief. -5.2. In the year 2006, what is the difference between the Imports(as % of merchandise exports) in Least developed countries and Imports(as % of merchandise exports) in Austria?
Keep it short and to the point. 10.11. In the year 2006, what is the difference between the Imports(as % of merchandise exports) of Least developed countries and Imports(as % of merchandise exports) of Denmark?
Your answer should be very brief. 4.66. In the year 2006, what is the difference between the Imports(as % of merchandise exports) in Least developed countries and Imports(as % of merchandise exports) in Swaziland?
Offer a very short reply. 0.46. In the year 2006, what is the difference between the Imports(as % of merchandise exports) in Austria and Imports(as % of merchandise exports) in Denmark?
Provide a succinct answer. -5.45. In the year 2006, what is the difference between the Imports(as % of merchandise exports) of Austria and Imports(as % of merchandise exports) of Swaziland?
Your answer should be compact. -9.64. In the year 2006, what is the difference between the Imports(as % of merchandise exports) in Denmark and Imports(as % of merchandise exports) in Swaziland?
Offer a terse response. -4.19. In the year 2007, what is the difference between the Imports(as % of merchandise exports) in Least developed countries and Imports(as % of merchandise exports) in Austria?
Your answer should be compact. 9.9. In the year 2007, what is the difference between the Imports(as % of merchandise exports) in Least developed countries and Imports(as % of merchandise exports) in Denmark?
Make the answer very short. 4.75. In the year 2007, what is the difference between the Imports(as % of merchandise exports) in Least developed countries and Imports(as % of merchandise exports) in Swaziland?
Your answer should be compact. -4.36. In the year 2007, what is the difference between the Imports(as % of merchandise exports) in Austria and Imports(as % of merchandise exports) in Denmark?
Give a very brief answer. -5.15. In the year 2007, what is the difference between the Imports(as % of merchandise exports) of Austria and Imports(as % of merchandise exports) of Swaziland?
Give a very brief answer. -14.26. In the year 2007, what is the difference between the Imports(as % of merchandise exports) in Denmark and Imports(as % of merchandise exports) in Swaziland?
Ensure brevity in your answer.  -9.11. What is the ratio of the Imports(as % of merchandise exports) in Least developed countries in 2000 to that in 2001?
Your answer should be compact. 1.03. What is the ratio of the Imports(as % of merchandise exports) of Austria in 2000 to that in 2001?
Provide a succinct answer. 0.94. What is the ratio of the Imports(as % of merchandise exports) in Denmark in 2000 to that in 2001?
Your answer should be compact. 0.98. What is the ratio of the Imports(as % of merchandise exports) of Swaziland in 2000 to that in 2001?
Ensure brevity in your answer.  1.08. What is the ratio of the Imports(as % of merchandise exports) in Least developed countries in 2000 to that in 2002?
Offer a terse response. 1.07. What is the ratio of the Imports(as % of merchandise exports) of Austria in 2000 to that in 2002?
Offer a very short reply. 0.88. What is the ratio of the Imports(as % of merchandise exports) of Denmark in 2000 to that in 2002?
Provide a short and direct response. 0.97. What is the ratio of the Imports(as % of merchandise exports) in Swaziland in 2000 to that in 2002?
Your answer should be very brief. 1.06. What is the ratio of the Imports(as % of merchandise exports) of Least developed countries in 2000 to that in 2003?
Make the answer very short. 1.04. What is the ratio of the Imports(as % of merchandise exports) of Austria in 2000 to that in 2003?
Offer a terse response. 0.89. What is the ratio of the Imports(as % of merchandise exports) of Denmark in 2000 to that in 2003?
Your answer should be compact. 0.92. What is the ratio of the Imports(as % of merchandise exports) of Swaziland in 2000 to that in 2003?
Provide a succinct answer. 1.14. What is the ratio of the Imports(as % of merchandise exports) of Least developed countries in 2000 to that in 2004?
Offer a terse response. 1.08. What is the ratio of the Imports(as % of merchandise exports) of Austria in 2000 to that in 2004?
Your answer should be compact. 0.92. What is the ratio of the Imports(as % of merchandise exports) of Denmark in 2000 to that in 2004?
Provide a short and direct response. 0.96. What is the ratio of the Imports(as % of merchandise exports) of Swaziland in 2000 to that in 2004?
Your answer should be very brief. 1.14. What is the ratio of the Imports(as % of merchandise exports) of Least developed countries in 2000 to that in 2005?
Make the answer very short. 1.15. What is the ratio of the Imports(as % of merchandise exports) of Austria in 2000 to that in 2005?
Ensure brevity in your answer.  0.89. What is the ratio of the Imports(as % of merchandise exports) in Denmark in 2000 to that in 2005?
Make the answer very short. 0.98. What is the ratio of the Imports(as % of merchandise exports) of Swaziland in 2000 to that in 2005?
Your response must be concise. 1.11. What is the ratio of the Imports(as % of merchandise exports) of Least developed countries in 2000 to that in 2006?
Offer a very short reply. 1.13. What is the ratio of the Imports(as % of merchandise exports) in Austria in 2000 to that in 2006?
Keep it short and to the point. 0.93. What is the ratio of the Imports(as % of merchandise exports) in Denmark in 2000 to that in 2006?
Make the answer very short. 1. What is the ratio of the Imports(as % of merchandise exports) of Swaziland in 2000 to that in 2006?
Make the answer very short. 1.21. What is the ratio of the Imports(as % of merchandise exports) in Least developed countries in 2000 to that in 2007?
Offer a very short reply. 1.12. What is the ratio of the Imports(as % of merchandise exports) of Austria in 2000 to that in 2007?
Provide a short and direct response. 0.87. What is the ratio of the Imports(as % of merchandise exports) of Swaziland in 2000 to that in 2007?
Provide a succinct answer. 0.91. What is the ratio of the Imports(as % of merchandise exports) in Least developed countries in 2001 to that in 2002?
Provide a succinct answer. 1.04. What is the ratio of the Imports(as % of merchandise exports) in Austria in 2001 to that in 2002?
Your answer should be compact. 0.94. What is the ratio of the Imports(as % of merchandise exports) in Swaziland in 2001 to that in 2002?
Provide a short and direct response. 0.98. What is the ratio of the Imports(as % of merchandise exports) of Least developed countries in 2001 to that in 2003?
Your answer should be compact. 1.01. What is the ratio of the Imports(as % of merchandise exports) in Austria in 2001 to that in 2003?
Offer a terse response. 0.94. What is the ratio of the Imports(as % of merchandise exports) in Denmark in 2001 to that in 2003?
Offer a terse response. 0.95. What is the ratio of the Imports(as % of merchandise exports) in Swaziland in 2001 to that in 2003?
Provide a succinct answer. 1.05. What is the ratio of the Imports(as % of merchandise exports) of Least developed countries in 2001 to that in 2004?
Your answer should be compact. 1.05. What is the ratio of the Imports(as % of merchandise exports) of Austria in 2001 to that in 2004?
Give a very brief answer. 0.98. What is the ratio of the Imports(as % of merchandise exports) of Denmark in 2001 to that in 2004?
Provide a short and direct response. 0.98. What is the ratio of the Imports(as % of merchandise exports) in Swaziland in 2001 to that in 2004?
Your answer should be very brief. 1.05. What is the ratio of the Imports(as % of merchandise exports) in Least developed countries in 2001 to that in 2005?
Give a very brief answer. 1.11. What is the ratio of the Imports(as % of merchandise exports) of Austria in 2001 to that in 2005?
Make the answer very short. 0.95. What is the ratio of the Imports(as % of merchandise exports) in Swaziland in 2001 to that in 2005?
Make the answer very short. 1.03. What is the ratio of the Imports(as % of merchandise exports) in Least developed countries in 2001 to that in 2006?
Offer a terse response. 1.1. What is the ratio of the Imports(as % of merchandise exports) in Austria in 2001 to that in 2006?
Keep it short and to the point. 0.99. What is the ratio of the Imports(as % of merchandise exports) in Denmark in 2001 to that in 2006?
Your response must be concise. 1.03. What is the ratio of the Imports(as % of merchandise exports) in Swaziland in 2001 to that in 2006?
Offer a terse response. 1.11. What is the ratio of the Imports(as % of merchandise exports) in Least developed countries in 2001 to that in 2007?
Provide a short and direct response. 1.09. What is the ratio of the Imports(as % of merchandise exports) in Austria in 2001 to that in 2007?
Your answer should be compact. 0.92. What is the ratio of the Imports(as % of merchandise exports) in Swaziland in 2001 to that in 2007?
Your answer should be very brief. 0.84. What is the ratio of the Imports(as % of merchandise exports) of Least developed countries in 2002 to that in 2003?
Give a very brief answer. 0.98. What is the ratio of the Imports(as % of merchandise exports) of Austria in 2002 to that in 2003?
Offer a very short reply. 1. What is the ratio of the Imports(as % of merchandise exports) of Denmark in 2002 to that in 2003?
Offer a very short reply. 0.96. What is the ratio of the Imports(as % of merchandise exports) in Swaziland in 2002 to that in 2003?
Provide a succinct answer. 1.07. What is the ratio of the Imports(as % of merchandise exports) of Least developed countries in 2002 to that in 2004?
Offer a terse response. 1.01. What is the ratio of the Imports(as % of merchandise exports) of Austria in 2002 to that in 2004?
Give a very brief answer. 1.04. What is the ratio of the Imports(as % of merchandise exports) of Swaziland in 2002 to that in 2004?
Offer a terse response. 1.07. What is the ratio of the Imports(as % of merchandise exports) in Least developed countries in 2002 to that in 2005?
Make the answer very short. 1.07. What is the ratio of the Imports(as % of merchandise exports) in Austria in 2002 to that in 2005?
Your answer should be compact. 1.01. What is the ratio of the Imports(as % of merchandise exports) of Denmark in 2002 to that in 2005?
Make the answer very short. 1.01. What is the ratio of the Imports(as % of merchandise exports) of Swaziland in 2002 to that in 2005?
Ensure brevity in your answer.  1.05. What is the ratio of the Imports(as % of merchandise exports) in Least developed countries in 2002 to that in 2006?
Keep it short and to the point. 1.06. What is the ratio of the Imports(as % of merchandise exports) of Austria in 2002 to that in 2006?
Give a very brief answer. 1.05. What is the ratio of the Imports(as % of merchandise exports) in Denmark in 2002 to that in 2006?
Provide a short and direct response. 1.04. What is the ratio of the Imports(as % of merchandise exports) of Swaziland in 2002 to that in 2006?
Your response must be concise. 1.13. What is the ratio of the Imports(as % of merchandise exports) of Least developed countries in 2002 to that in 2007?
Provide a succinct answer. 1.05. What is the ratio of the Imports(as % of merchandise exports) in Austria in 2002 to that in 2007?
Your answer should be very brief. 0.98. What is the ratio of the Imports(as % of merchandise exports) of Denmark in 2002 to that in 2007?
Give a very brief answer. 1.03. What is the ratio of the Imports(as % of merchandise exports) of Swaziland in 2002 to that in 2007?
Provide a succinct answer. 0.86. What is the ratio of the Imports(as % of merchandise exports) of Least developed countries in 2003 to that in 2004?
Offer a terse response. 1.04. What is the ratio of the Imports(as % of merchandise exports) of Austria in 2003 to that in 2004?
Your response must be concise. 1.04. What is the ratio of the Imports(as % of merchandise exports) in Denmark in 2003 to that in 2004?
Ensure brevity in your answer.  1.04. What is the ratio of the Imports(as % of merchandise exports) in Swaziland in 2003 to that in 2004?
Your answer should be very brief. 1. What is the ratio of the Imports(as % of merchandise exports) of Least developed countries in 2003 to that in 2005?
Ensure brevity in your answer.  1.1. What is the ratio of the Imports(as % of merchandise exports) of Austria in 2003 to that in 2005?
Provide a succinct answer. 1.01. What is the ratio of the Imports(as % of merchandise exports) of Denmark in 2003 to that in 2005?
Provide a succinct answer. 1.06. What is the ratio of the Imports(as % of merchandise exports) of Swaziland in 2003 to that in 2005?
Give a very brief answer. 0.98. What is the ratio of the Imports(as % of merchandise exports) of Least developed countries in 2003 to that in 2006?
Your response must be concise. 1.09. What is the ratio of the Imports(as % of merchandise exports) of Austria in 2003 to that in 2006?
Provide a succinct answer. 1.05. What is the ratio of the Imports(as % of merchandise exports) of Denmark in 2003 to that in 2006?
Provide a short and direct response. 1.09. What is the ratio of the Imports(as % of merchandise exports) of Swaziland in 2003 to that in 2006?
Provide a succinct answer. 1.06. What is the ratio of the Imports(as % of merchandise exports) of Least developed countries in 2003 to that in 2007?
Provide a short and direct response. 1.07. What is the ratio of the Imports(as % of merchandise exports) in Austria in 2003 to that in 2007?
Offer a terse response. 0.98. What is the ratio of the Imports(as % of merchandise exports) of Denmark in 2003 to that in 2007?
Offer a very short reply. 1.07. What is the ratio of the Imports(as % of merchandise exports) of Swaziland in 2003 to that in 2007?
Offer a very short reply. 0.8. What is the ratio of the Imports(as % of merchandise exports) in Least developed countries in 2004 to that in 2005?
Keep it short and to the point. 1.06. What is the ratio of the Imports(as % of merchandise exports) of Austria in 2004 to that in 2005?
Provide a succinct answer. 0.97. What is the ratio of the Imports(as % of merchandise exports) in Denmark in 2004 to that in 2005?
Offer a very short reply. 1.02. What is the ratio of the Imports(as % of merchandise exports) of Swaziland in 2004 to that in 2005?
Make the answer very short. 0.98. What is the ratio of the Imports(as % of merchandise exports) in Least developed countries in 2004 to that in 2006?
Offer a terse response. 1.05. What is the ratio of the Imports(as % of merchandise exports) in Austria in 2004 to that in 2006?
Your response must be concise. 1.01. What is the ratio of the Imports(as % of merchandise exports) of Denmark in 2004 to that in 2006?
Give a very brief answer. 1.05. What is the ratio of the Imports(as % of merchandise exports) of Swaziland in 2004 to that in 2006?
Keep it short and to the point. 1.06. What is the ratio of the Imports(as % of merchandise exports) of Least developed countries in 2004 to that in 2007?
Give a very brief answer. 1.04. What is the ratio of the Imports(as % of merchandise exports) in Austria in 2004 to that in 2007?
Your answer should be compact. 0.94. What is the ratio of the Imports(as % of merchandise exports) of Denmark in 2004 to that in 2007?
Offer a very short reply. 1.04. What is the ratio of the Imports(as % of merchandise exports) of Swaziland in 2004 to that in 2007?
Keep it short and to the point. 0.8. What is the ratio of the Imports(as % of merchandise exports) in Austria in 2005 to that in 2006?
Your answer should be compact. 1.04. What is the ratio of the Imports(as % of merchandise exports) in Denmark in 2005 to that in 2006?
Provide a succinct answer. 1.02. What is the ratio of the Imports(as % of merchandise exports) in Swaziland in 2005 to that in 2006?
Provide a succinct answer. 1.08. What is the ratio of the Imports(as % of merchandise exports) in Least developed countries in 2005 to that in 2007?
Give a very brief answer. 0.98. What is the ratio of the Imports(as % of merchandise exports) of Austria in 2005 to that in 2007?
Your response must be concise. 0.97. What is the ratio of the Imports(as % of merchandise exports) in Denmark in 2005 to that in 2007?
Your response must be concise. 1.01. What is the ratio of the Imports(as % of merchandise exports) in Swaziland in 2005 to that in 2007?
Keep it short and to the point. 0.82. What is the ratio of the Imports(as % of merchandise exports) of Least developed countries in 2006 to that in 2007?
Your answer should be very brief. 0.99. What is the ratio of the Imports(as % of merchandise exports) of Austria in 2006 to that in 2007?
Your answer should be very brief. 0.93. What is the ratio of the Imports(as % of merchandise exports) of Denmark in 2006 to that in 2007?
Your answer should be very brief. 0.99. What is the ratio of the Imports(as % of merchandise exports) in Swaziland in 2006 to that in 2007?
Offer a terse response. 0.75. What is the difference between the highest and the second highest Imports(as % of merchandise exports) of Least developed countries?
Your answer should be compact. 0.54. What is the difference between the highest and the second highest Imports(as % of merchandise exports) of Austria?
Offer a very short reply. 0.12. What is the difference between the highest and the second highest Imports(as % of merchandise exports) of Denmark?
Offer a terse response. 0.44. What is the difference between the highest and the second highest Imports(as % of merchandise exports) in Swaziland?
Give a very brief answer. 1.83. What is the difference between the highest and the lowest Imports(as % of merchandise exports) in Least developed countries?
Give a very brief answer. 2.29. What is the difference between the highest and the lowest Imports(as % of merchandise exports) in Austria?
Give a very brief answer. 0.84. What is the difference between the highest and the lowest Imports(as % of merchandise exports) of Denmark?
Your response must be concise. 0.97. What is the difference between the highest and the lowest Imports(as % of merchandise exports) in Swaziland?
Your answer should be compact. 5.04. 